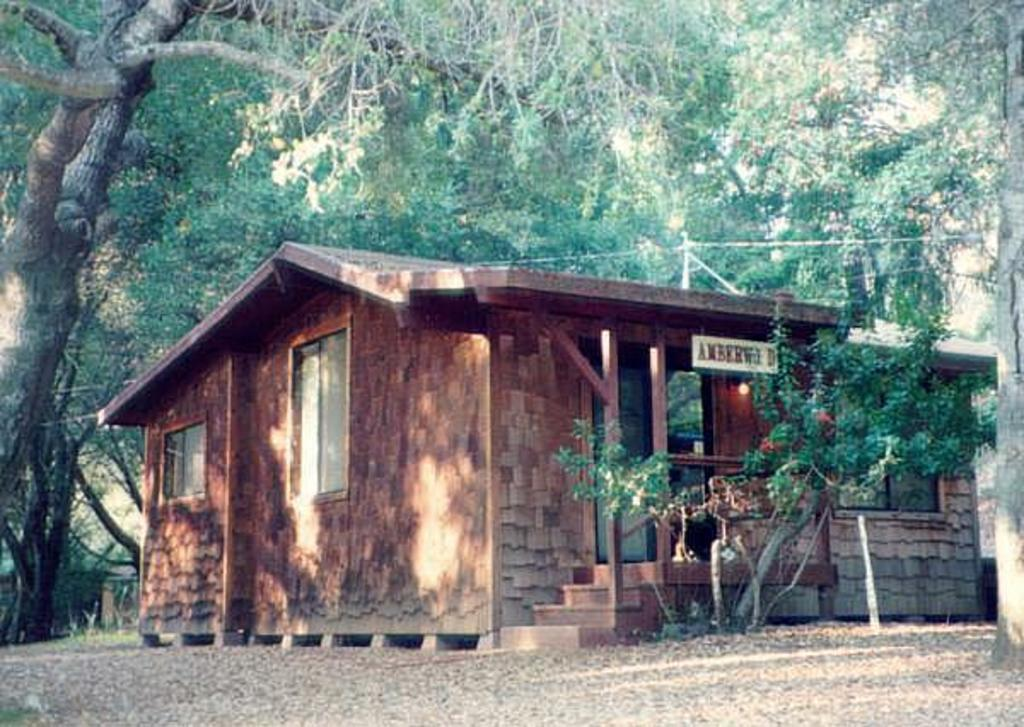What is the main object in the foreground of the image? There is a plant in the image. What structure is visible behind the plant? There is a house behind the plant. What type of vegetation is visible behind the house? There are trees behind the house. What type of pump can be seen on the face of the machine in the image? There is no machine or pump present in the image; it features a plant, a house, and trees. 